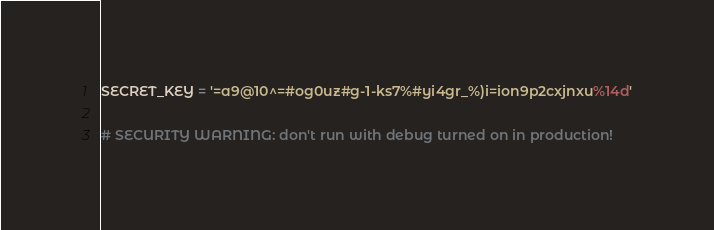<code> <loc_0><loc_0><loc_500><loc_500><_Python_>SECRET_KEY = '=a9@10^=#og0uz#g-1-ks7%#yi4gr_%)i=ion9p2cxjnxu%14d'

# SECURITY WARNING: don't run with debug turned on in production!</code> 